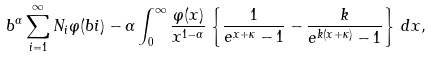<formula> <loc_0><loc_0><loc_500><loc_500>b ^ { \alpha } \sum _ { i = 1 } ^ { \infty } N _ { i } \varphi ( b i ) - \alpha \int _ { 0 } ^ { \infty } \frac { \varphi ( x ) } { x ^ { 1 - \alpha } } \left \{ \frac { 1 } { e ^ { x + \kappa } - 1 } - \frac { k } { e ^ { k ( x + \kappa ) } - 1 } \right \} \, d x ,</formula> 